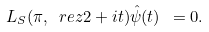<formula> <loc_0><loc_0><loc_500><loc_500>L _ { S } ( \pi , \ r e z { 2 } + i t ) \hat { \psi } ( t ) \ = 0 .</formula> 